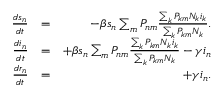<formula> <loc_0><loc_0><loc_500><loc_500>\begin{array} { r l r } { \frac { d s _ { n } } { d t } } & { = } & { - \beta s _ { n } \sum _ { m } P _ { n m } \frac { \sum _ { k } P _ { k m } N _ { k } i _ { k } } { \sum _ { k } P _ { k m } N _ { k } } . } \\ { \frac { d i _ { n } } { d t } } & { = } & { + \beta s _ { n } \sum _ { m } P _ { n m } \frac { \sum _ { k } P _ { k m } N _ { k } i _ { k } } { \sum _ { k } P _ { k m } N _ { k } } - \gamma i _ { n } } \\ { \frac { d r _ { n } } { d t } } & { = } & { + \gamma i _ { n } . } \end{array}</formula> 